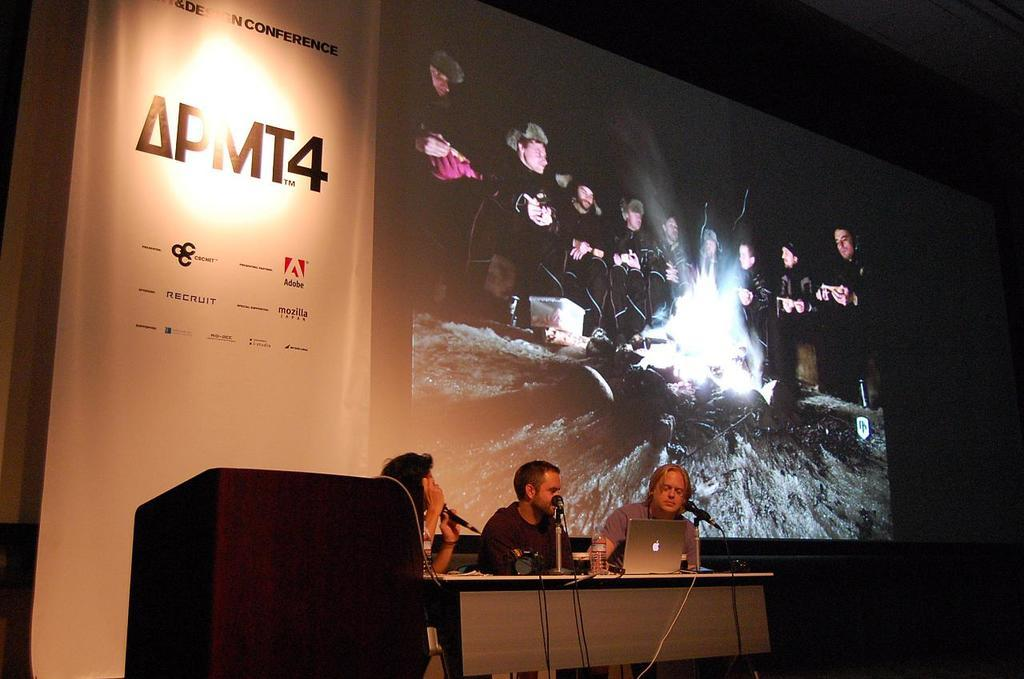How many people are in the image? There are three people in the image. What are the people doing in the image? The people are sitting in front of a table. What object can be seen on the table? There is a laptop on the table. What type of furniture is present in the image? There is a desk in the image. What is the purpose of the projector screen in the image? The projector screen is likely used for presentations or displaying visuals. Can you see an owl sitting on the desk in the image? No, there is no owl present in the image. Is there a crib visible in the image? No, there is no crib visible in the image. 